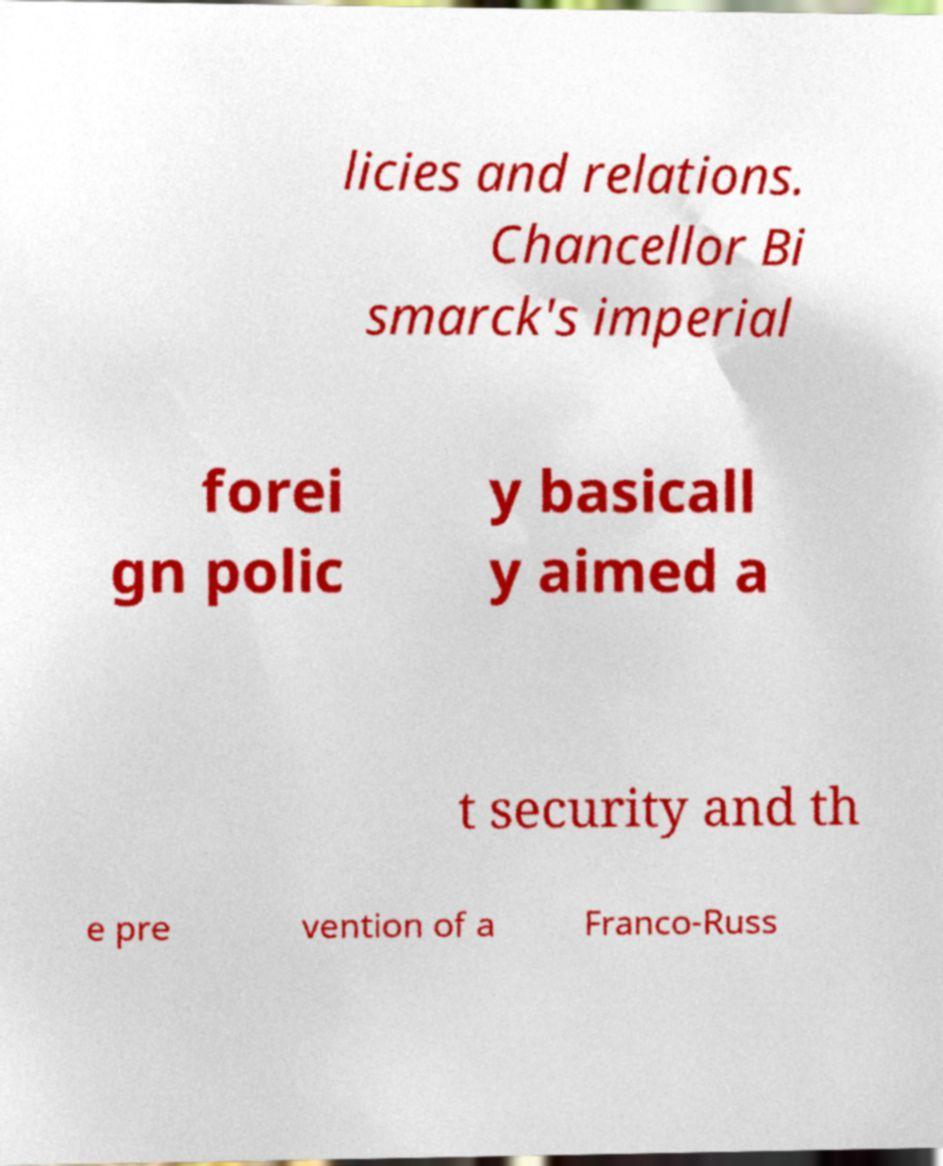There's text embedded in this image that I need extracted. Can you transcribe it verbatim? licies and relations. Chancellor Bi smarck's imperial forei gn polic y basicall y aimed a t security and th e pre vention of a Franco-Russ 